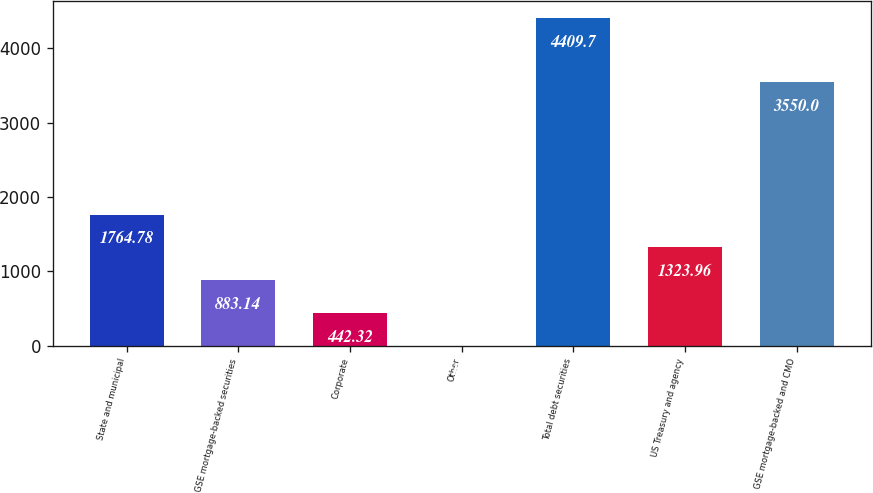Convert chart. <chart><loc_0><loc_0><loc_500><loc_500><bar_chart><fcel>State and municipal<fcel>GSE mortgage-backed securities<fcel>Corporate<fcel>Other<fcel>Total debt securities<fcel>US Treasury and agency<fcel>GSE mortgage-backed and CMO<nl><fcel>1764.78<fcel>883.14<fcel>442.32<fcel>1.5<fcel>4409.7<fcel>1323.96<fcel>3550<nl></chart> 